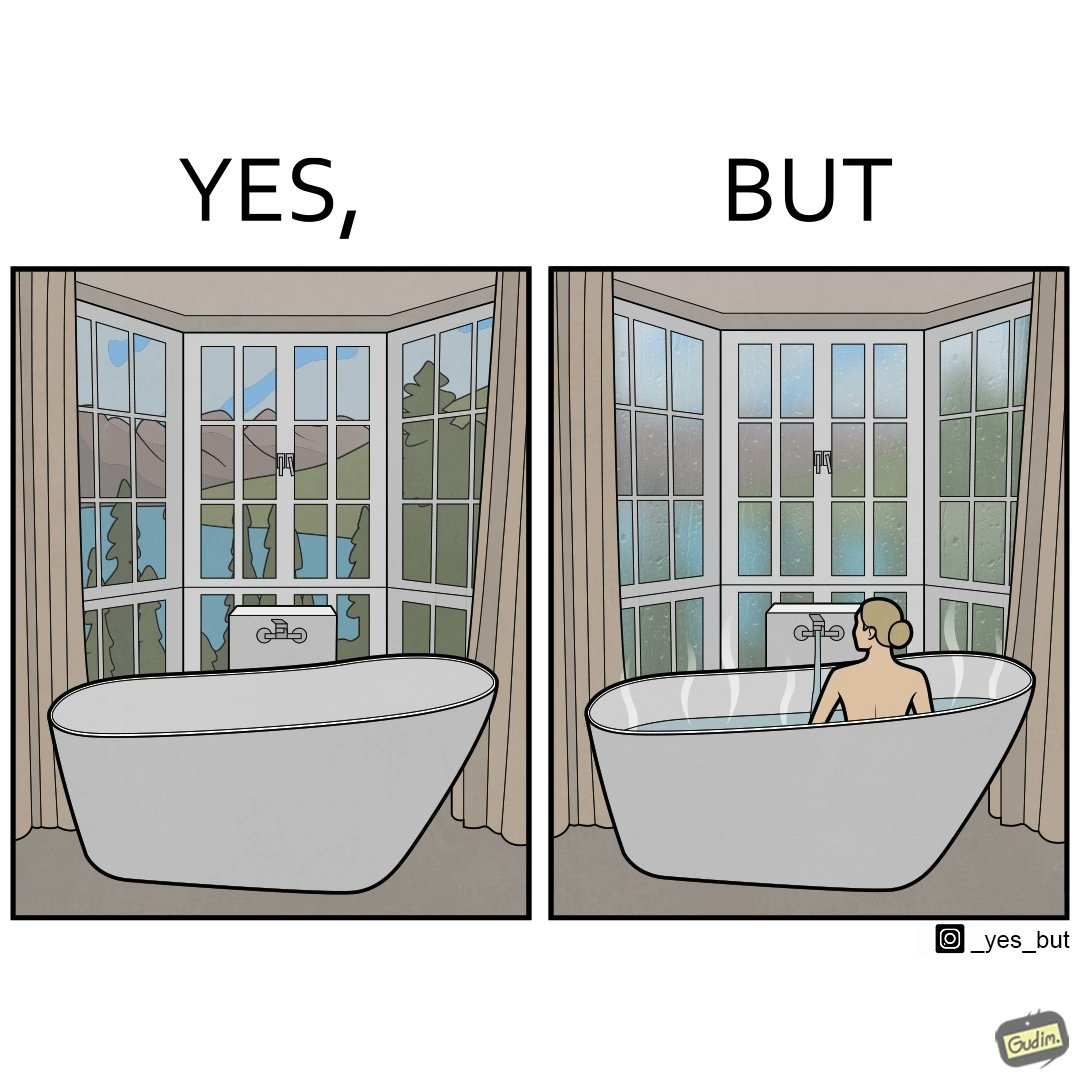Is there satirical content in this image? Yes, this image is satirical. 